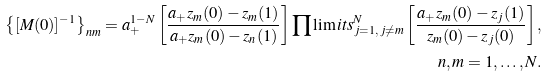Convert formula to latex. <formula><loc_0><loc_0><loc_500><loc_500>\left \{ [ M ( 0 ) ] ^ { - 1 } \right \} _ { n m } = a _ { + } ^ { 1 - N } \left [ \frac { a _ { + } z _ { m } ( 0 ) - z _ { m } ( 1 ) } { a _ { + } z _ { m } ( 0 ) - z _ { n } ( 1 ) } \right ] \prod \lim i t s _ { j = 1 , \, j \neq m } ^ { N } \left [ \frac { a _ { + } z _ { m } ( 0 ) - z _ { j } ( 1 ) } { z _ { m } ( 0 ) - z _ { j } ( 0 ) } \right ] , \\ n , m = 1 , \dots , N .</formula> 